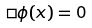<formula> <loc_0><loc_0><loc_500><loc_500>\Box \phi ( x ) = 0</formula> 